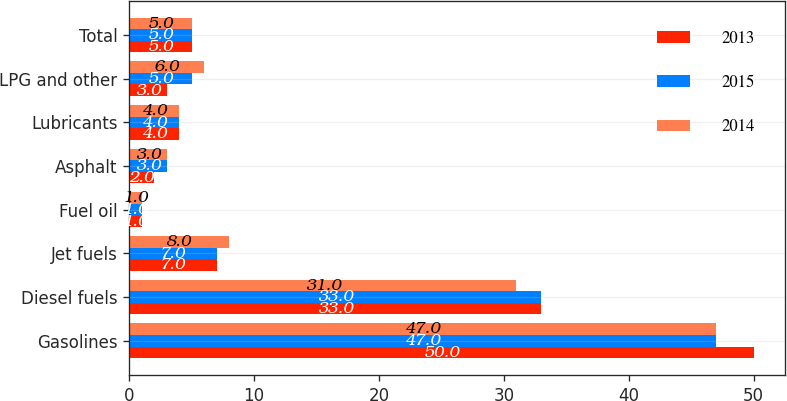Convert chart. <chart><loc_0><loc_0><loc_500><loc_500><stacked_bar_chart><ecel><fcel>Gasolines<fcel>Diesel fuels<fcel>Jet fuels<fcel>Fuel oil<fcel>Asphalt<fcel>Lubricants<fcel>LPG and other<fcel>Total<nl><fcel>2013<fcel>50<fcel>33<fcel>7<fcel>1<fcel>2<fcel>4<fcel>3<fcel>5<nl><fcel>2015<fcel>47<fcel>33<fcel>7<fcel>1<fcel>3<fcel>4<fcel>5<fcel>5<nl><fcel>2014<fcel>47<fcel>31<fcel>8<fcel>1<fcel>3<fcel>4<fcel>6<fcel>5<nl></chart> 